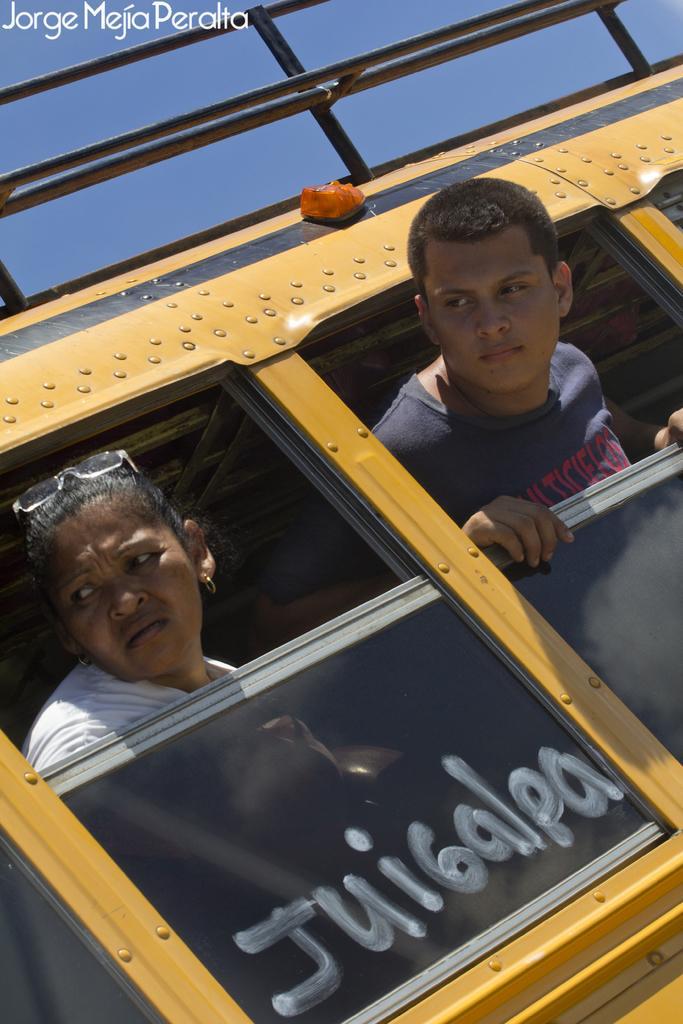Describe this image in one or two sentences. 2 people are present in a yellow bus and watching outside. 